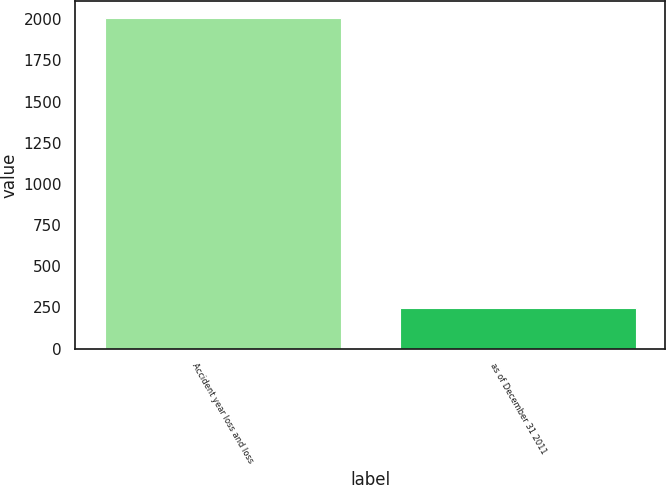Convert chart. <chart><loc_0><loc_0><loc_500><loc_500><bar_chart><fcel>Accident year loss and loss<fcel>as of December 31 2011<nl><fcel>2009<fcel>246<nl></chart> 